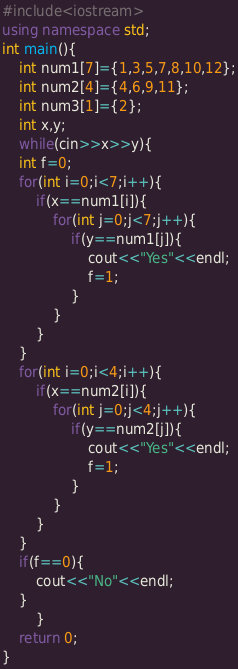Convert code to text. <code><loc_0><loc_0><loc_500><loc_500><_C++_>#include<iostream>
using namespace std;
int main(){
    int num1[7]={1,3,5,7,8,10,12};
    int num2[4]={4,6,9,11};
    int num3[1]={2};
    int x,y;
    while(cin>>x>>y){
    int f=0;
    for(int i=0;i<7;i++){
        if(x==num1[i]){
            for(int j=0;j<7;j++){
                if(y==num1[j]){
                    cout<<"Yes"<<endl;
                    f=1;
                }
            }
        }
    }
    for(int i=0;i<4;i++){
        if(x==num2[i]){
            for(int j=0;j<4;j++){
                if(y==num2[j]){
                    cout<<"Yes"<<endl;
                    f=1;
                }
            }
        }
    }
    if(f==0){
        cout<<"No"<<endl;
    }
        }
    return 0;
}
</code> 